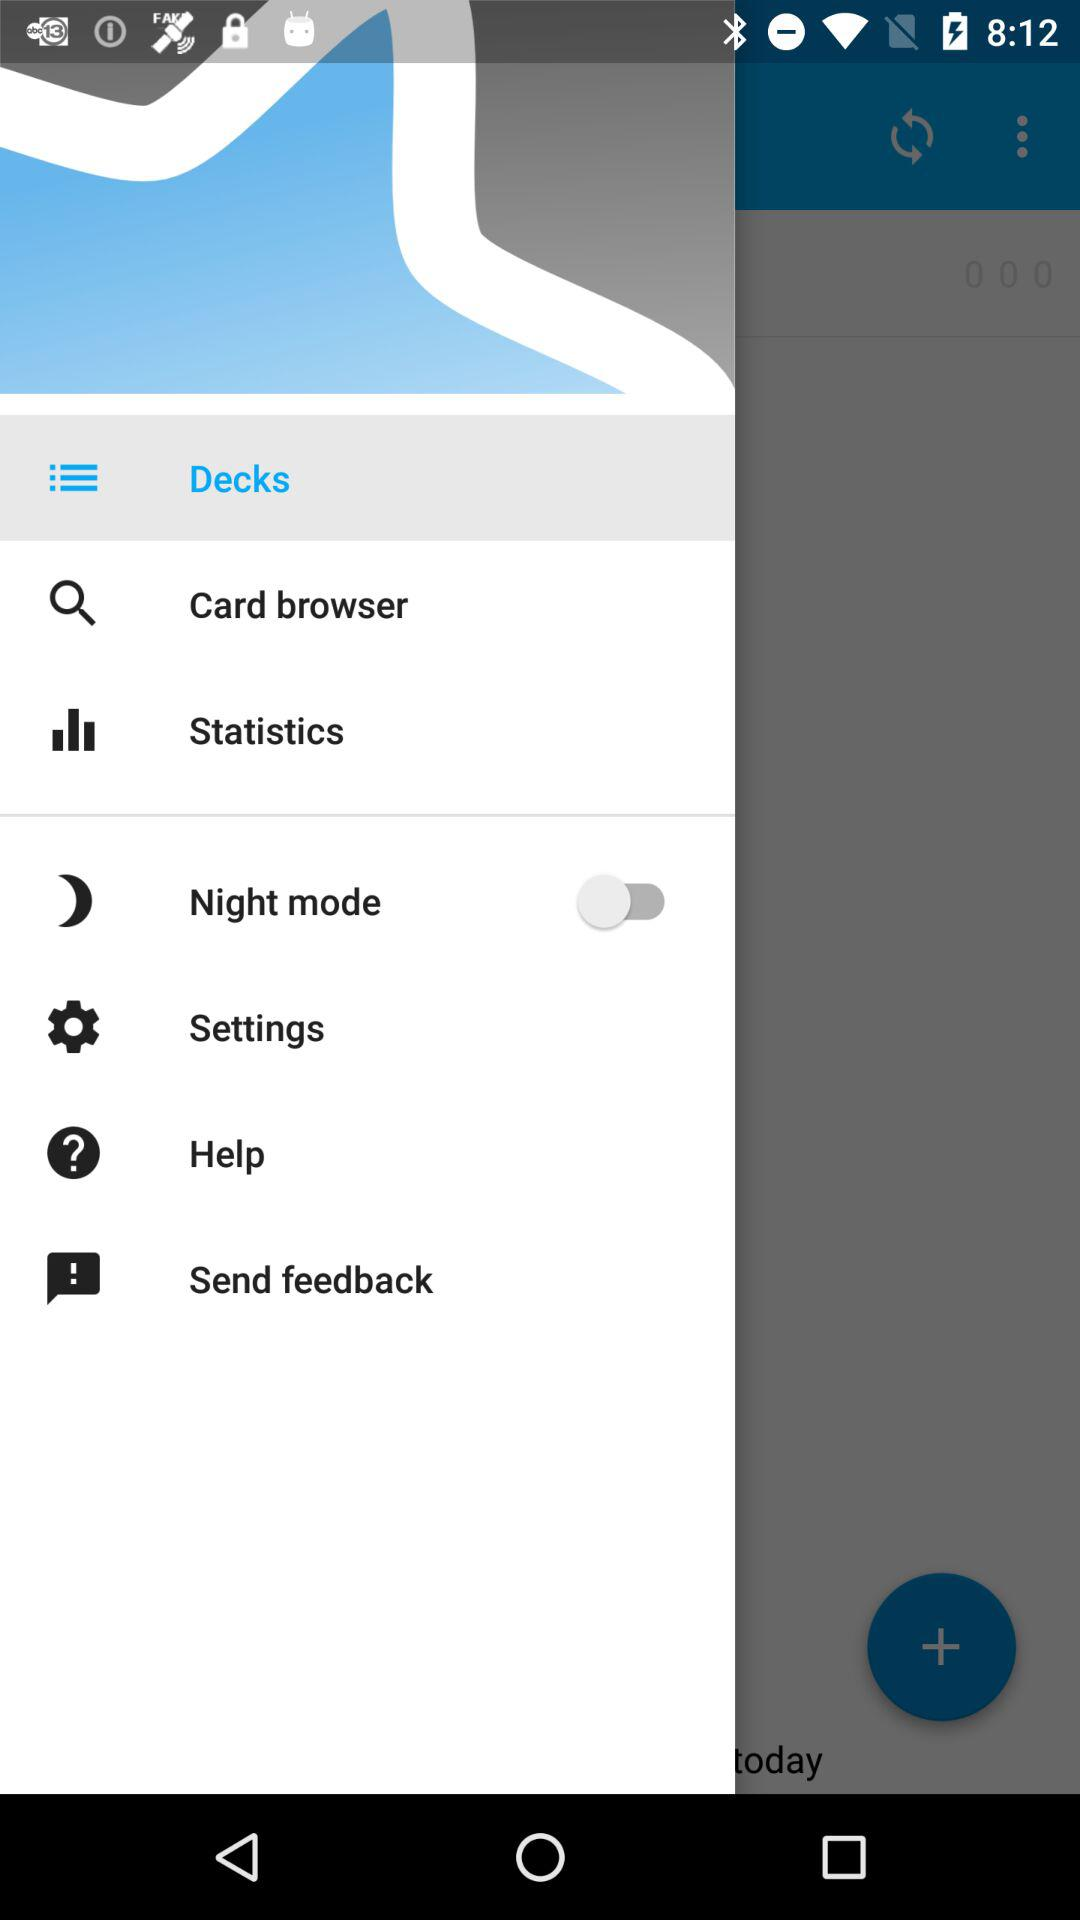Which item has been selected? The selected item is "Decks". 